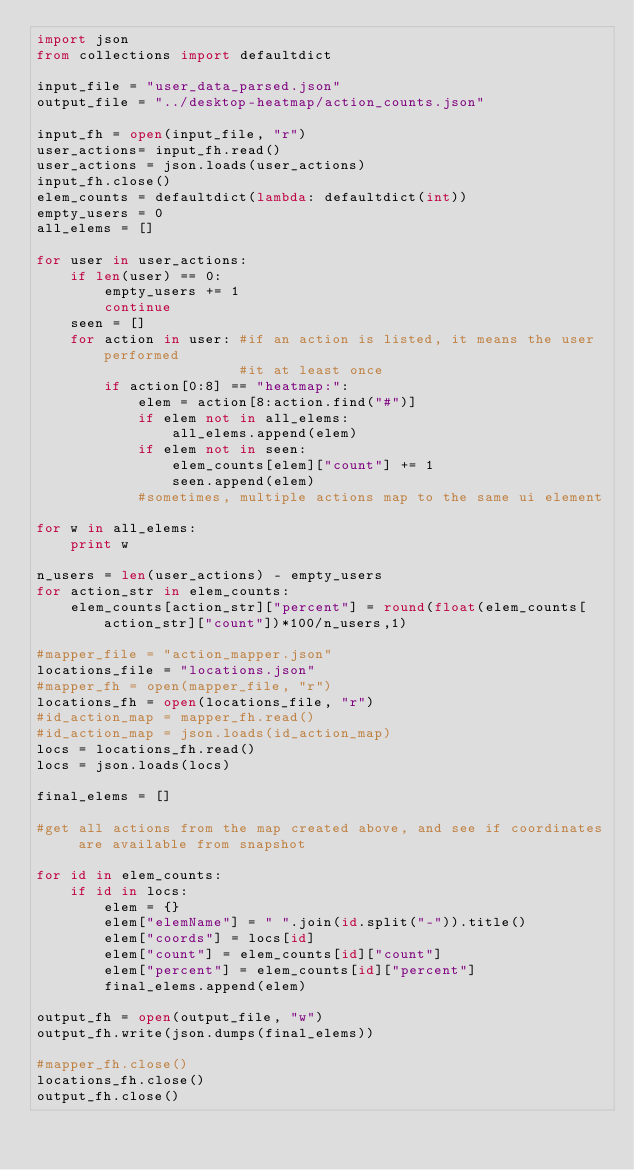Convert code to text. <code><loc_0><loc_0><loc_500><loc_500><_Python_>import json
from collections import defaultdict

input_file = "user_data_parsed.json"
output_file = "../desktop-heatmap/action_counts.json"

input_fh = open(input_file, "r")
user_actions= input_fh.read()
user_actions = json.loads(user_actions)
input_fh.close()
elem_counts = defaultdict(lambda: defaultdict(int))
empty_users = 0
all_elems = []

for user in user_actions:
    if len(user) == 0:
        empty_users += 1
        continue
    seen = []
    for action in user: #if an action is listed, it means the user performed
                        #it at least once
        if action[0:8] == "heatmap:":
            elem = action[8:action.find("#")]
            if elem not in all_elems:
                all_elems.append(elem)
            if elem not in seen:
                elem_counts[elem]["count"] += 1
                seen.append(elem)
            #sometimes, multiple actions map to the same ui element

for w in all_elems:    
    print w

n_users = len(user_actions) - empty_users
for action_str in elem_counts:
    elem_counts[action_str]["percent"] = round(float(elem_counts[action_str]["count"])*100/n_users,1)

#mapper_file = "action_mapper.json"
locations_file = "locations.json"
#mapper_fh = open(mapper_file, "r")
locations_fh = open(locations_file, "r")
#id_action_map = mapper_fh.read()
#id_action_map = json.loads(id_action_map)
locs = locations_fh.read()
locs = json.loads(locs)

final_elems = []

#get all actions from the map created above, and see if coordinates are available from snapshot

for id in elem_counts:
    if id in locs:
        elem = {}
        elem["elemName"] = " ".join(id.split("-")).title()
        elem["coords"] = locs[id]
        elem["count"] = elem_counts[id]["count"]
        elem["percent"] = elem_counts[id]["percent"]
        final_elems.append(elem)

output_fh = open(output_file, "w")
output_fh.write(json.dumps(final_elems))

#mapper_fh.close()
locations_fh.close()
output_fh.close()




                </code> 